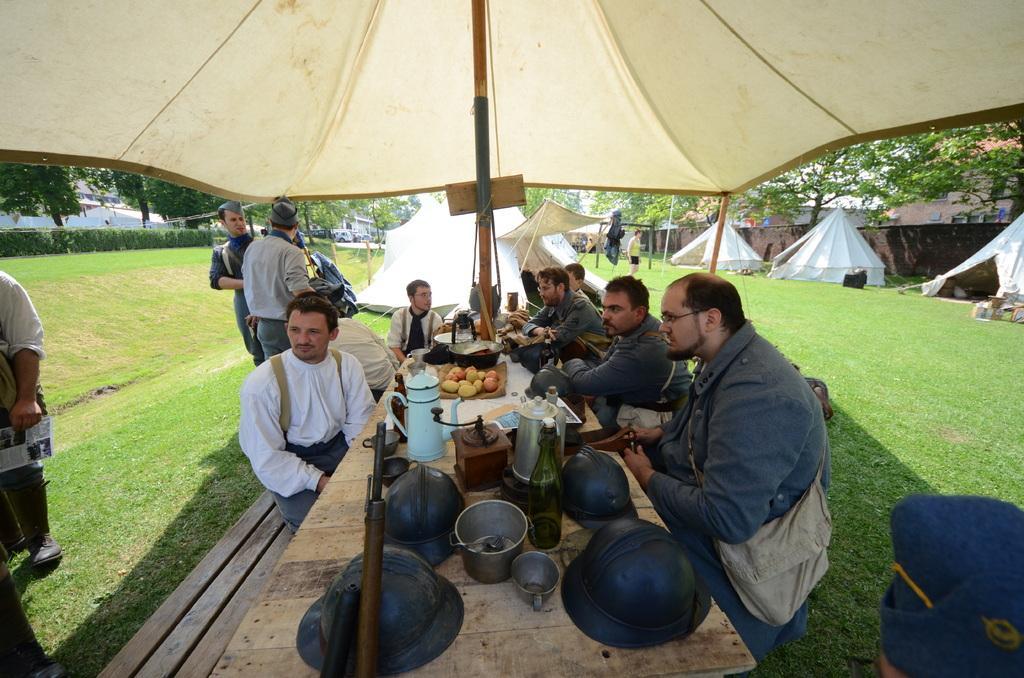Please provide a concise description of this image. In this picture there is a dining table in the center of the image and there are people on the right side of the image, there are tents on the right side of the image and there is grassland around the area of the image. 